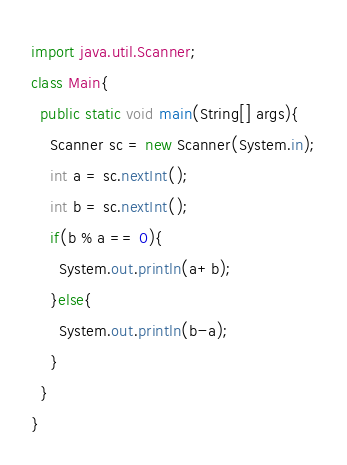<code> <loc_0><loc_0><loc_500><loc_500><_Java_>import java.util.Scanner;
class Main{
  public static void main(String[] args){
    Scanner sc = new Scanner(System.in);
    int a = sc.nextInt();
    int b = sc.nextInt();
    if(b % a == 0){
      System.out.println(a+b);
    }else{
      System.out.println(b-a);
    }
  }
}
</code> 